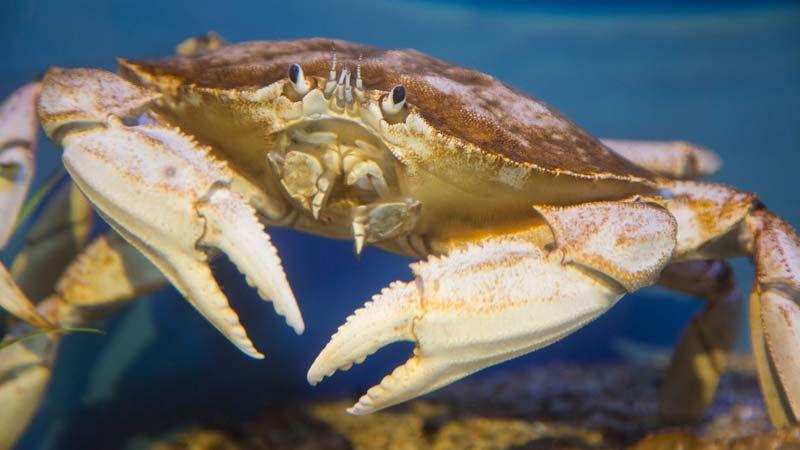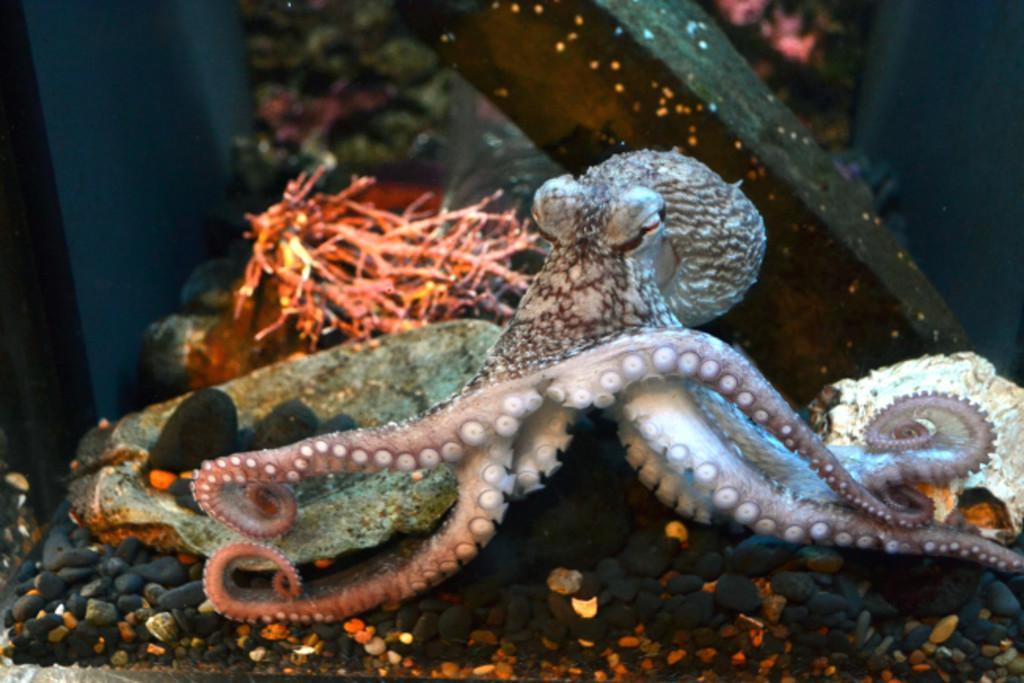The first image is the image on the left, the second image is the image on the right. Examine the images to the left and right. Is the description "In at least one image there is a single hand holding two of the crabs legs." accurate? Answer yes or no. No. The first image is the image on the left, the second image is the image on the right. Assess this claim about the two images: "A bare hand is touching two of a crab's claws in one image.". Correct or not? Answer yes or no. No. 